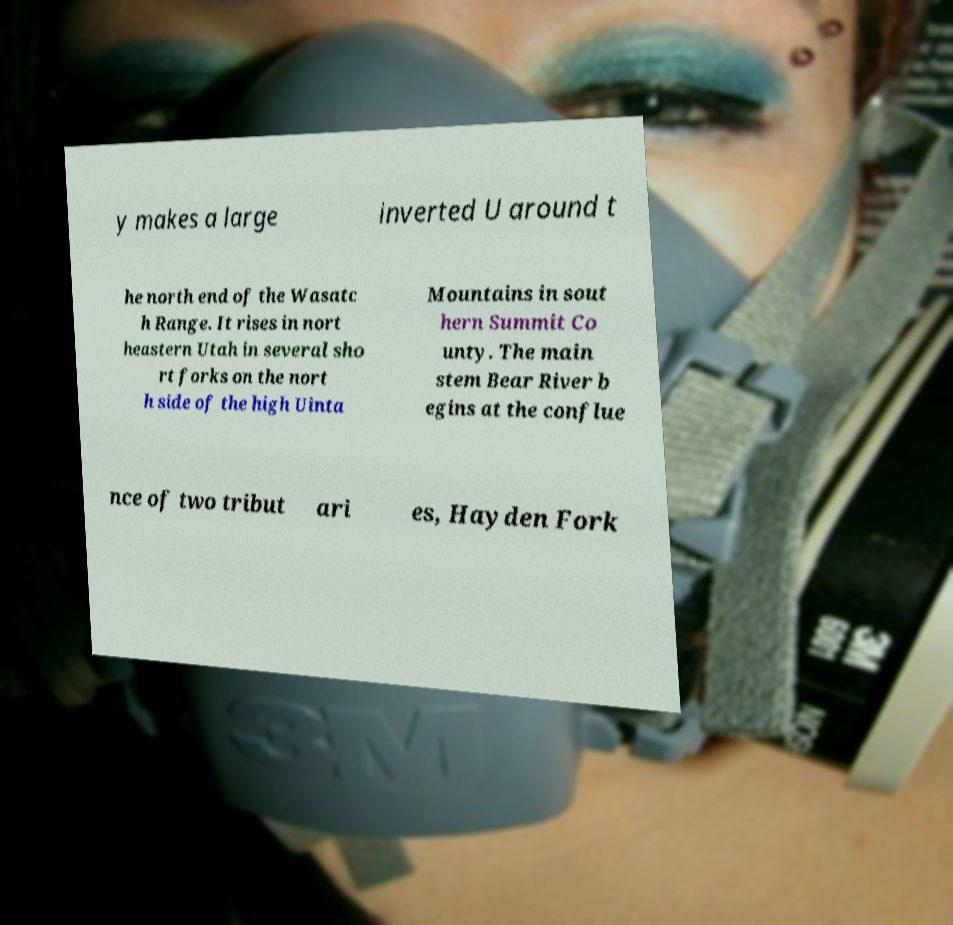What messages or text are displayed in this image? I need them in a readable, typed format. y makes a large inverted U around t he north end of the Wasatc h Range. It rises in nort heastern Utah in several sho rt forks on the nort h side of the high Uinta Mountains in sout hern Summit Co unty. The main stem Bear River b egins at the conflue nce of two tribut ari es, Hayden Fork 